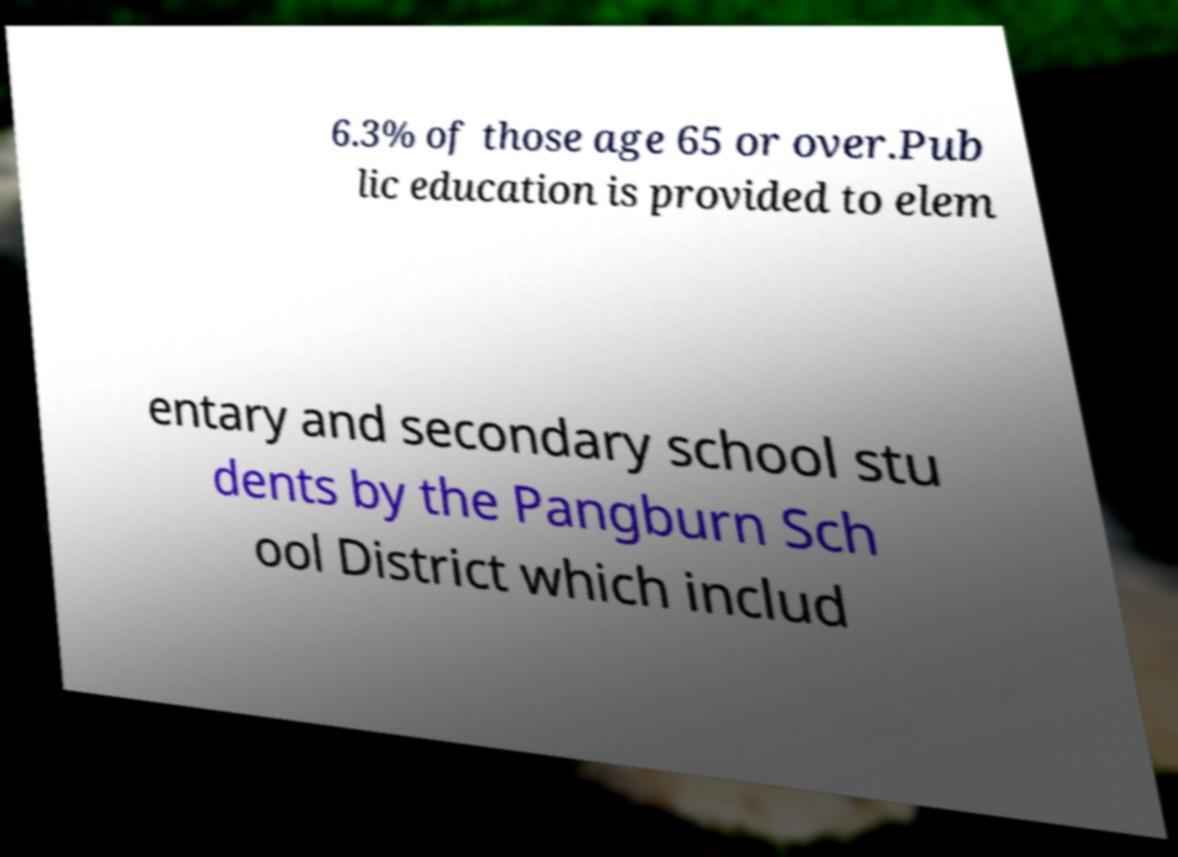Could you extract and type out the text from this image? 6.3% of those age 65 or over.Pub lic education is provided to elem entary and secondary school stu dents by the Pangburn Sch ool District which includ 